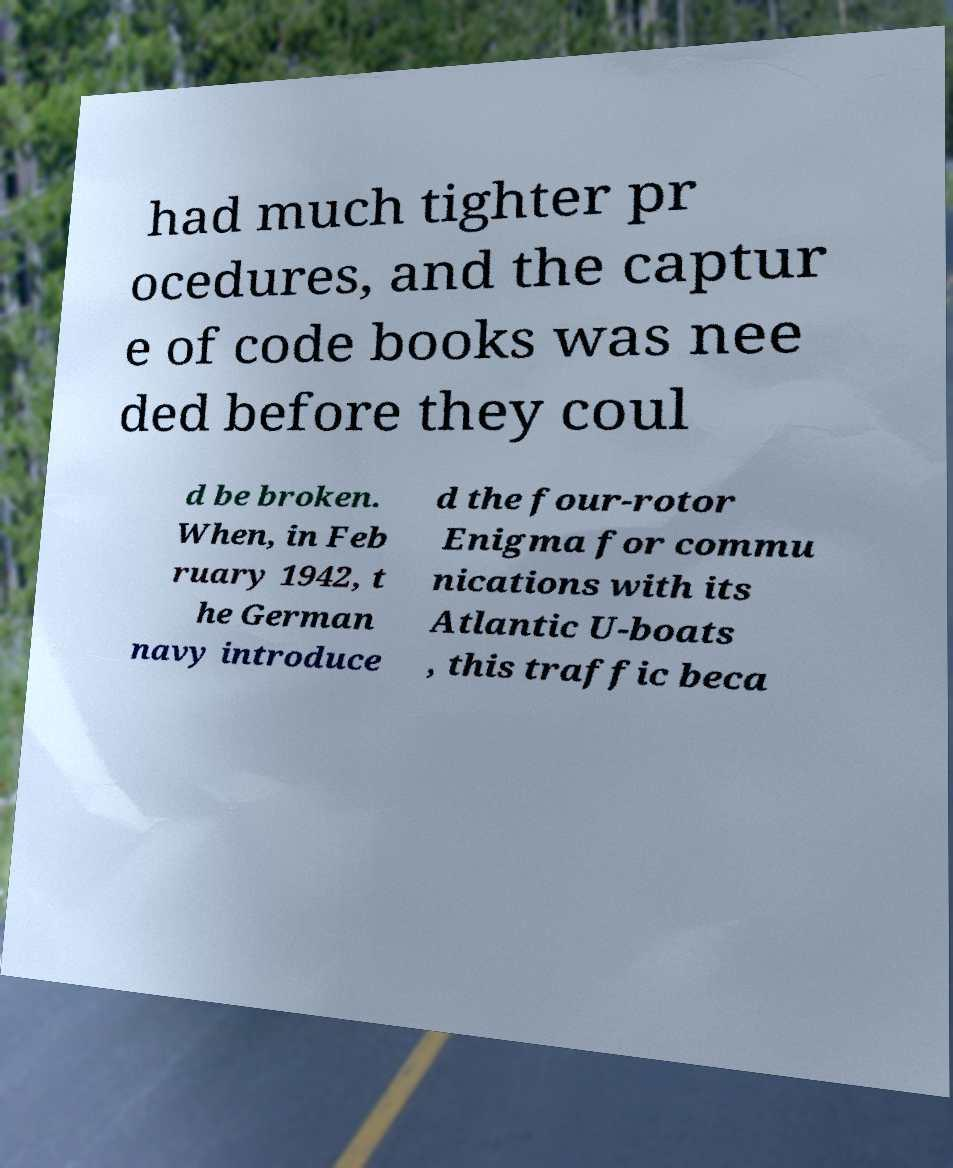Could you extract and type out the text from this image? had much tighter pr ocedures, and the captur e of code books was nee ded before they coul d be broken. When, in Feb ruary 1942, t he German navy introduce d the four-rotor Enigma for commu nications with its Atlantic U-boats , this traffic beca 